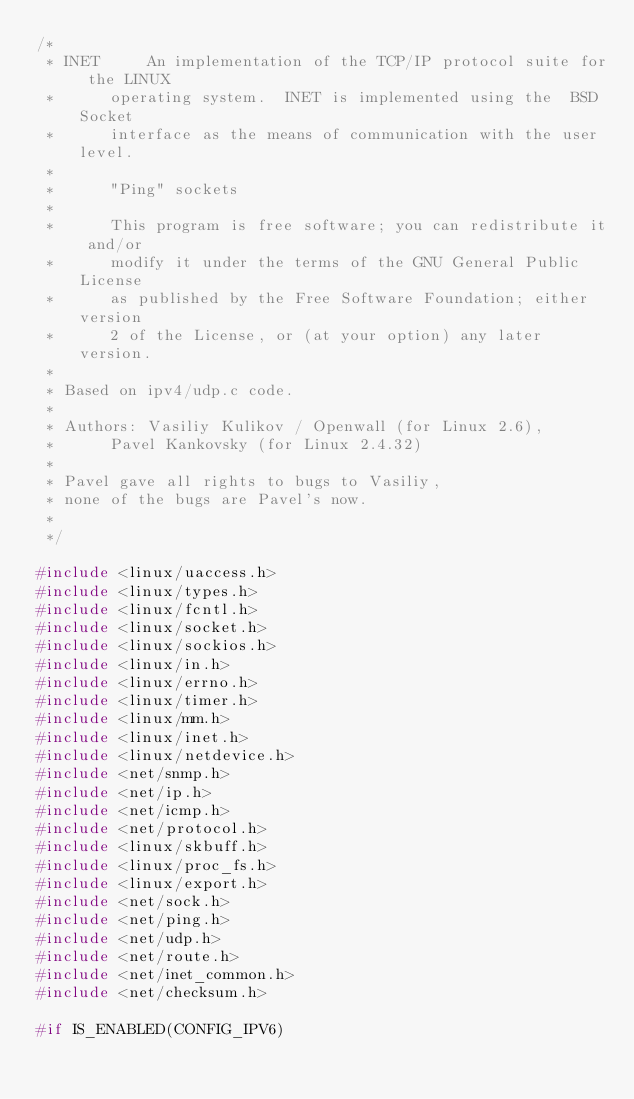<code> <loc_0><loc_0><loc_500><loc_500><_C_>/*
 * INET		An implementation of the TCP/IP protocol suite for the LINUX
 *		operating system.  INET is implemented using the  BSD Socket
 *		interface as the means of communication with the user level.
 *
 *		"Ping" sockets
 *
 *		This program is free software; you can redistribute it and/or
 *		modify it under the terms of the GNU General Public License
 *		as published by the Free Software Foundation; either version
 *		2 of the License, or (at your option) any later version.
 *
 * Based on ipv4/udp.c code.
 *
 * Authors:	Vasiliy Kulikov / Openwall (for Linux 2.6),
 *		Pavel Kankovsky (for Linux 2.4.32)
 *
 * Pavel gave all rights to bugs to Vasiliy,
 * none of the bugs are Pavel's now.
 *
 */

#include <linux/uaccess.h>
#include <linux/types.h>
#include <linux/fcntl.h>
#include <linux/socket.h>
#include <linux/sockios.h>
#include <linux/in.h>
#include <linux/errno.h>
#include <linux/timer.h>
#include <linux/mm.h>
#include <linux/inet.h>
#include <linux/netdevice.h>
#include <net/snmp.h>
#include <net/ip.h>
#include <net/icmp.h>
#include <net/protocol.h>
#include <linux/skbuff.h>
#include <linux/proc_fs.h>
#include <linux/export.h>
#include <net/sock.h>
#include <net/ping.h>
#include <net/udp.h>
#include <net/route.h>
#include <net/inet_common.h>
#include <net/checksum.h>

#if IS_ENABLED(CONFIG_IPV6)</code> 